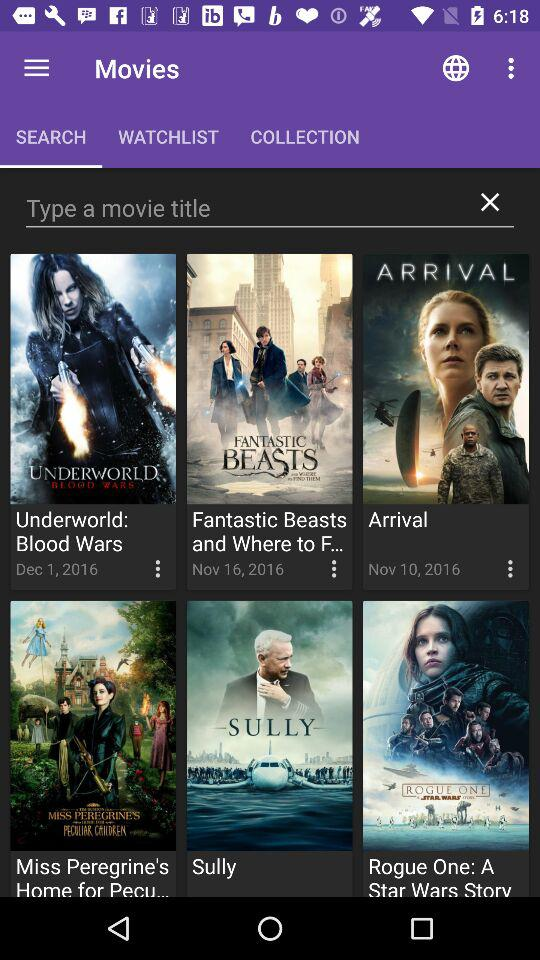How many movies have the release date of December 1, 2016?
Answer the question using a single word or phrase. 1 